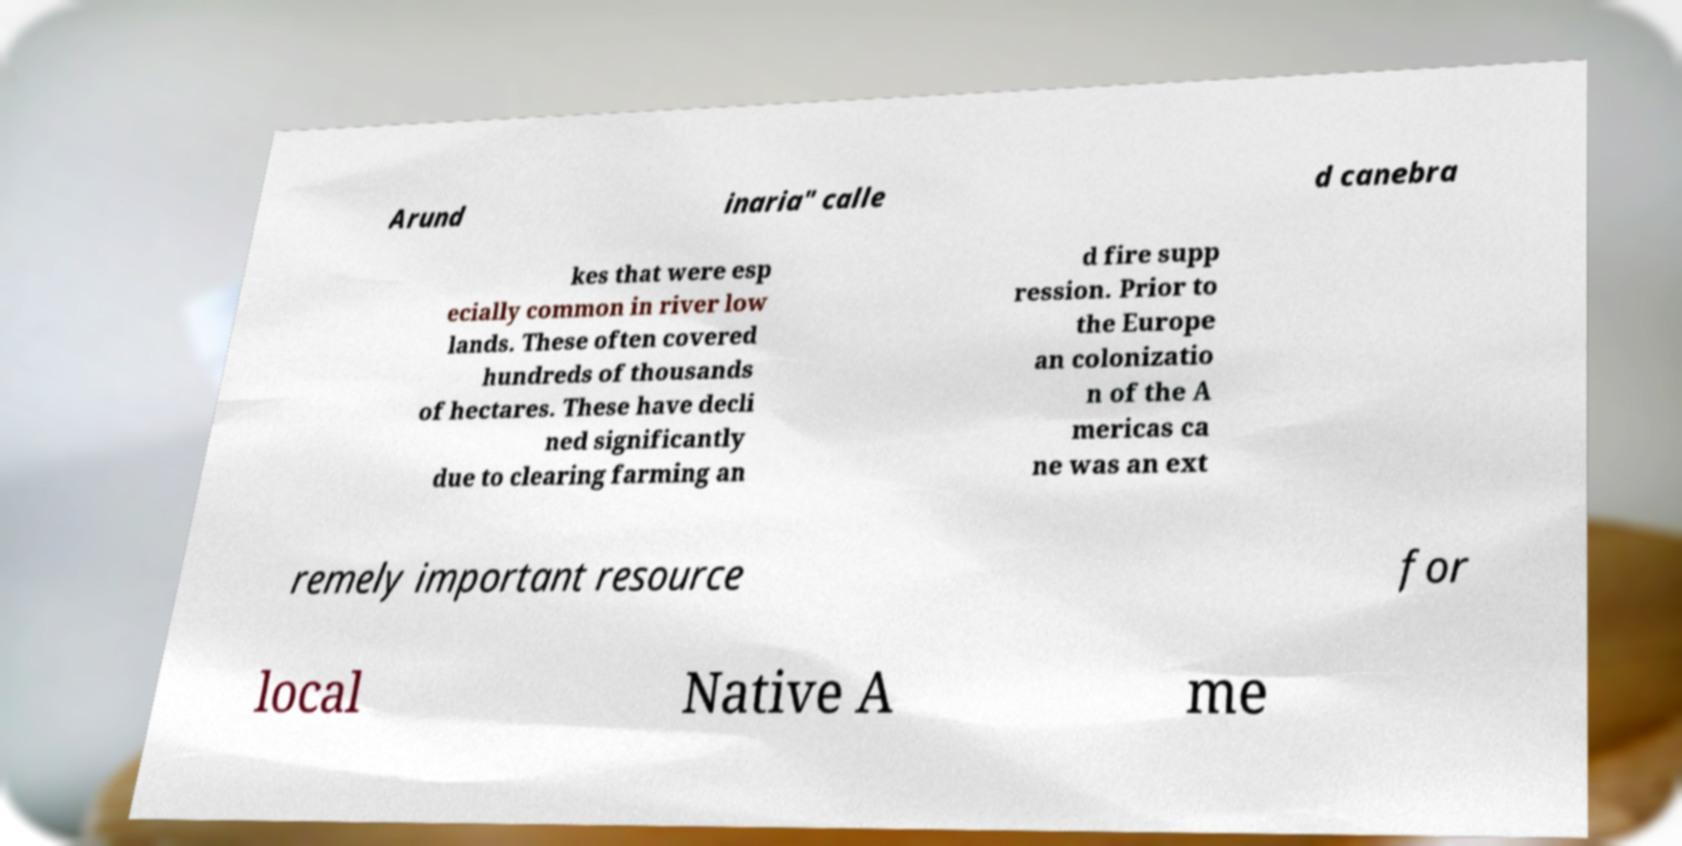Please read and relay the text visible in this image. What does it say? Arund inaria" calle d canebra kes that were esp ecially common in river low lands. These often covered hundreds of thousands of hectares. These have decli ned significantly due to clearing farming an d fire supp ression. Prior to the Europe an colonizatio n of the A mericas ca ne was an ext remely important resource for local Native A me 